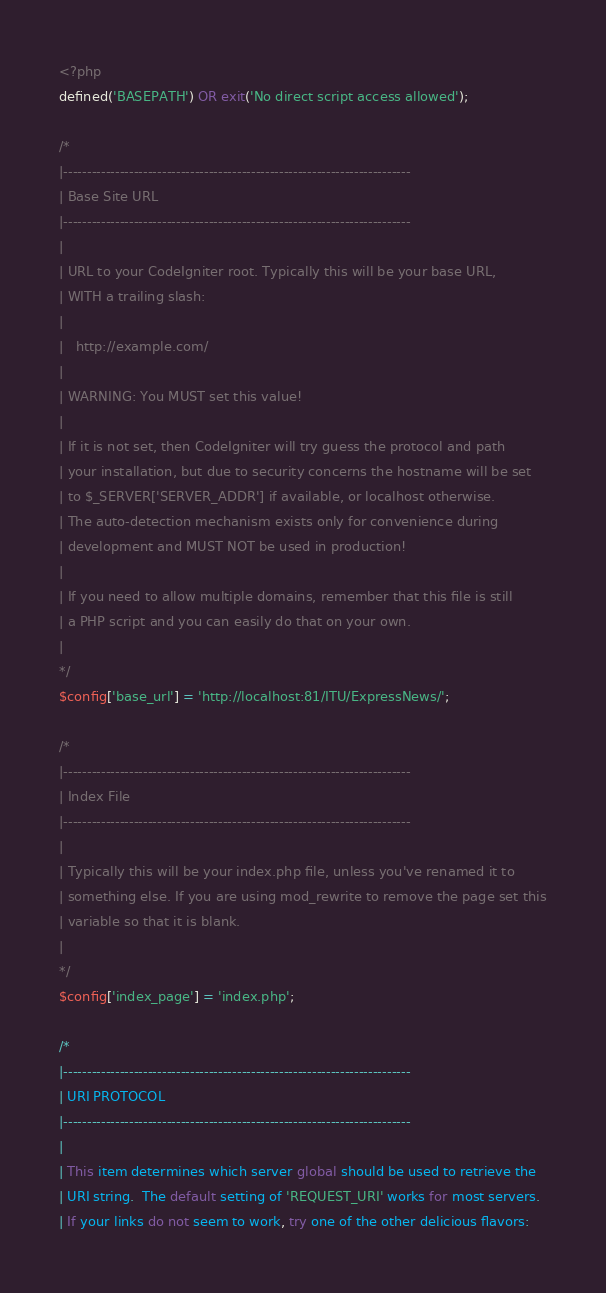<code> <loc_0><loc_0><loc_500><loc_500><_PHP_><?php
defined('BASEPATH') OR exit('No direct script access allowed');

/*
|--------------------------------------------------------------------------
| Base Site URL
|--------------------------------------------------------------------------
|
| URL to your CodeIgniter root. Typically this will be your base URL,
| WITH a trailing slash:
|
|	http://example.com/
|
| WARNING: You MUST set this value!
|
| If it is not set, then CodeIgniter will try guess the protocol and path
| your installation, but due to security concerns the hostname will be set
| to $_SERVER['SERVER_ADDR'] if available, or localhost otherwise.
| The auto-detection mechanism exists only for convenience during
| development and MUST NOT be used in production!
|
| If you need to allow multiple domains, remember that this file is still
| a PHP script and you can easily do that on your own.
|
*/
$config['base_url'] = 'http://localhost:81/ITU/ExpressNews/';

/*
|--------------------------------------------------------------------------
| Index File
|--------------------------------------------------------------------------
|
| Typically this will be your index.php file, unless you've renamed it to
| something else. If you are using mod_rewrite to remove the page set this
| variable so that it is blank.
|
*/
$config['index_page'] = 'index.php';

/*
|--------------------------------------------------------------------------
| URI PROTOCOL
|--------------------------------------------------------------------------
|
| This item determines which server global should be used to retrieve the
| URI string.  The default setting of 'REQUEST_URI' works for most servers.
| If your links do not seem to work, try one of the other delicious flavors:</code> 